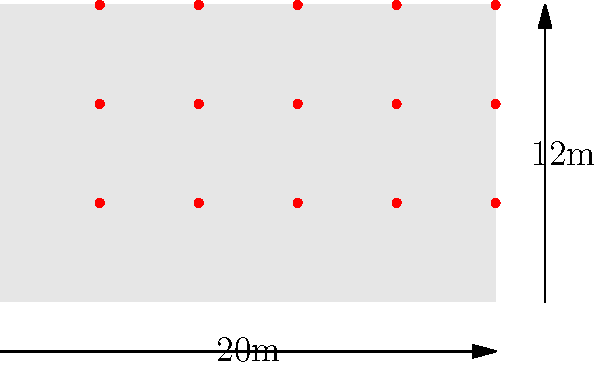For an upcoming freestyle motocross event in Saint Paul, Minnesota, you need to calculate the load-bearing capacity of a temporary grandstand. The grandstand measures 20m wide and 12m high, with an expected capacity of 500 spectators. If the average weight of a spectator is 75 kg and the safety factor is 1.5, what is the minimum total load-bearing capacity required for the grandstand structure? To calculate the minimum total load-bearing capacity of the grandstand, we need to follow these steps:

1. Calculate the total weight of the spectators:
   $$ \text{Total weight} = \text{Number of spectators} \times \text{Average weight} $$
   $$ \text{Total weight} = 500 \times 75 \text{ kg} = 37,500 \text{ kg} $$

2. Convert the weight from kilograms to Newtons:
   $$ \text{Force} = \text{Mass} \times \text{Acceleration due to gravity} $$
   $$ \text{Force} = 37,500 \text{ kg} \times 9.81 \text{ m/s}^2 = 367,875 \text{ N} $$

3. Apply the safety factor:
   $$ \text{Required capacity} = \text{Force} \times \text{Safety factor} $$
   $$ \text{Required capacity} = 367,875 \text{ N} \times 1.5 = 551,812.5 \text{ N} $$

4. Convert the result to kilonewtons (kN) for a more manageable unit:
   $$ \text{Required capacity in kN} = 551,812.5 \text{ N} \div 1000 = 551.8125 \text{ kN} $$

Therefore, the minimum total load-bearing capacity required for the grandstand structure is approximately 551.8 kN.
Answer: 551.8 kN 